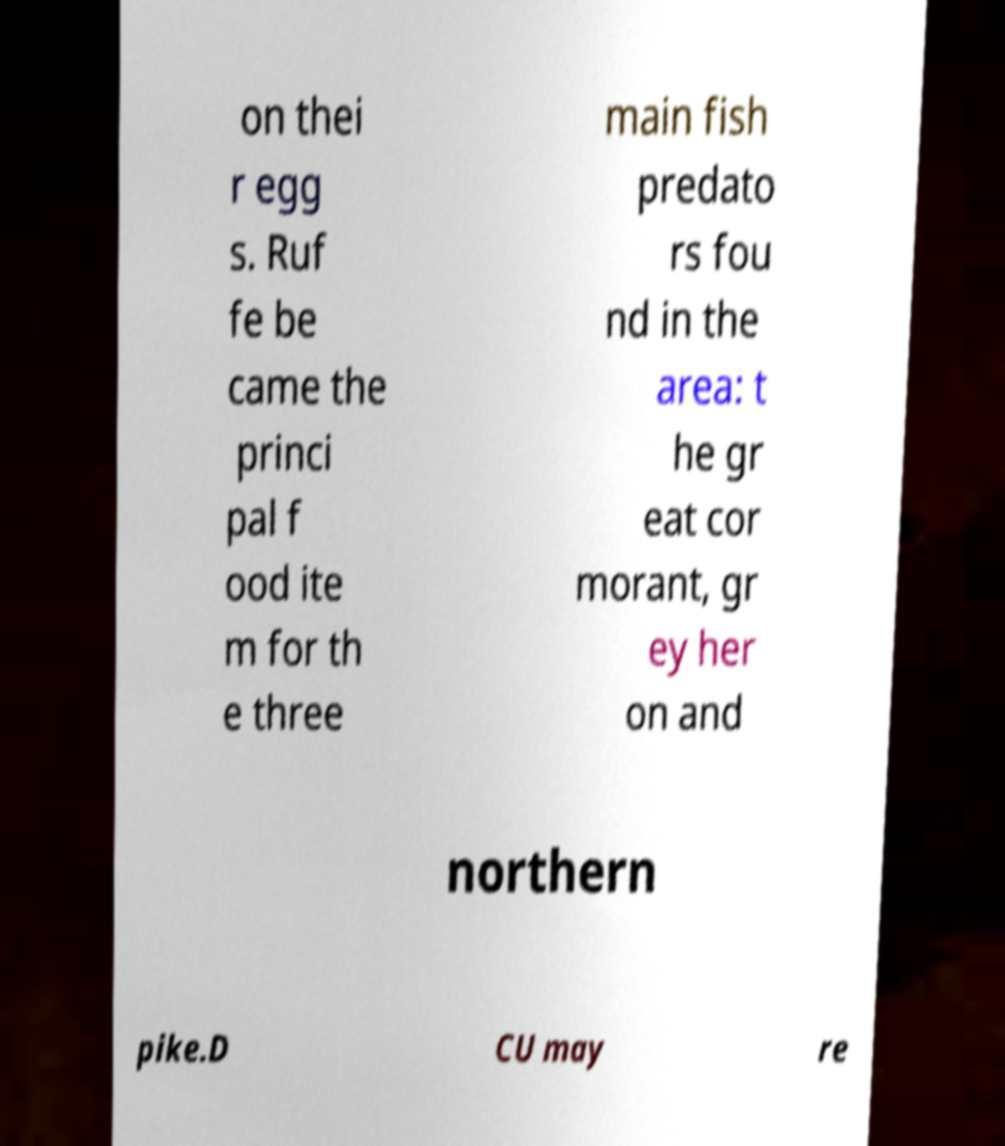Can you read and provide the text displayed in the image?This photo seems to have some interesting text. Can you extract and type it out for me? on thei r egg s. Ruf fe be came the princi pal f ood ite m for th e three main fish predato rs fou nd in the area: t he gr eat cor morant, gr ey her on and northern pike.D CU may re 